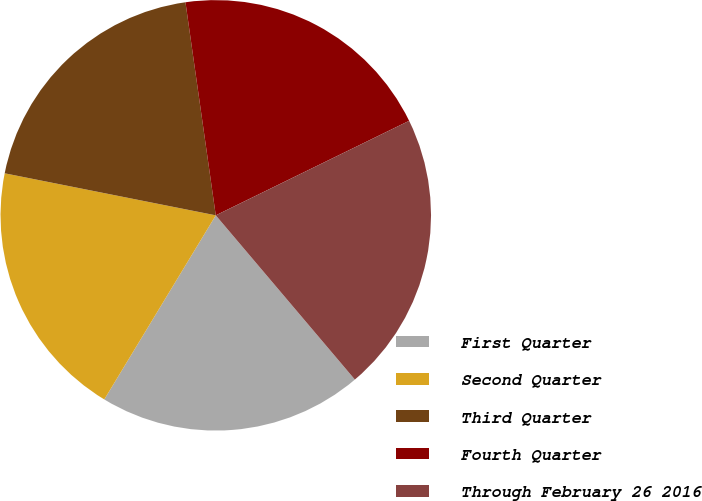<chart> <loc_0><loc_0><loc_500><loc_500><pie_chart><fcel>First Quarter<fcel>Second Quarter<fcel>Third Quarter<fcel>Fourth Quarter<fcel>Through February 26 2016<nl><fcel>19.85%<fcel>19.46%<fcel>19.62%<fcel>20.01%<fcel>21.05%<nl></chart> 